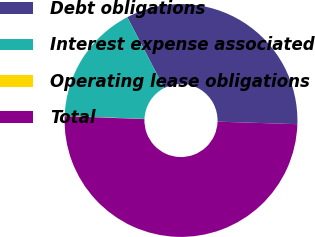Convert chart. <chart><loc_0><loc_0><loc_500><loc_500><pie_chart><fcel>Debt obligations<fcel>Interest expense associated<fcel>Operating lease obligations<fcel>Total<nl><fcel>33.13%<fcel>16.73%<fcel>0.05%<fcel>50.08%<nl></chart> 